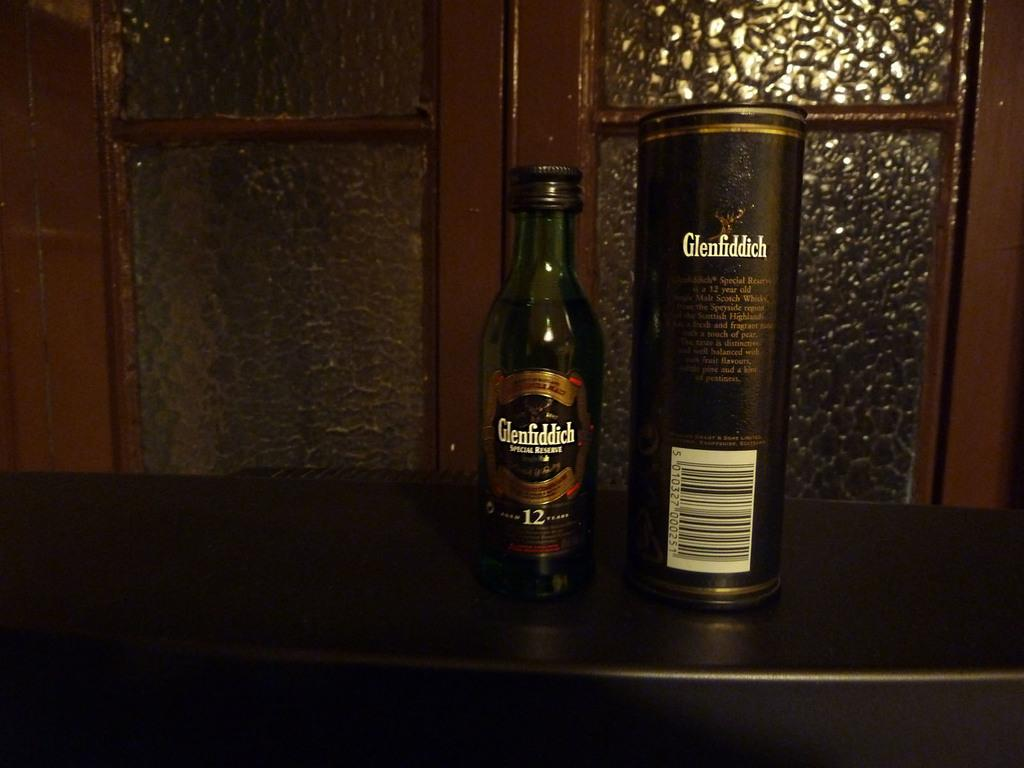What objects are on the table in the image? There is a bottle and a tin on the table in the image. Can you describe the window visible in the image? Unfortunately, the facts provided do not give any details about the window, so we cannot describe it. How many objects are on the table in the image? There are two objects on the table in the image: a bottle and a tin. What type of food is being prepared on the stage in the image? There is no stage or food preparation visible in the image. 